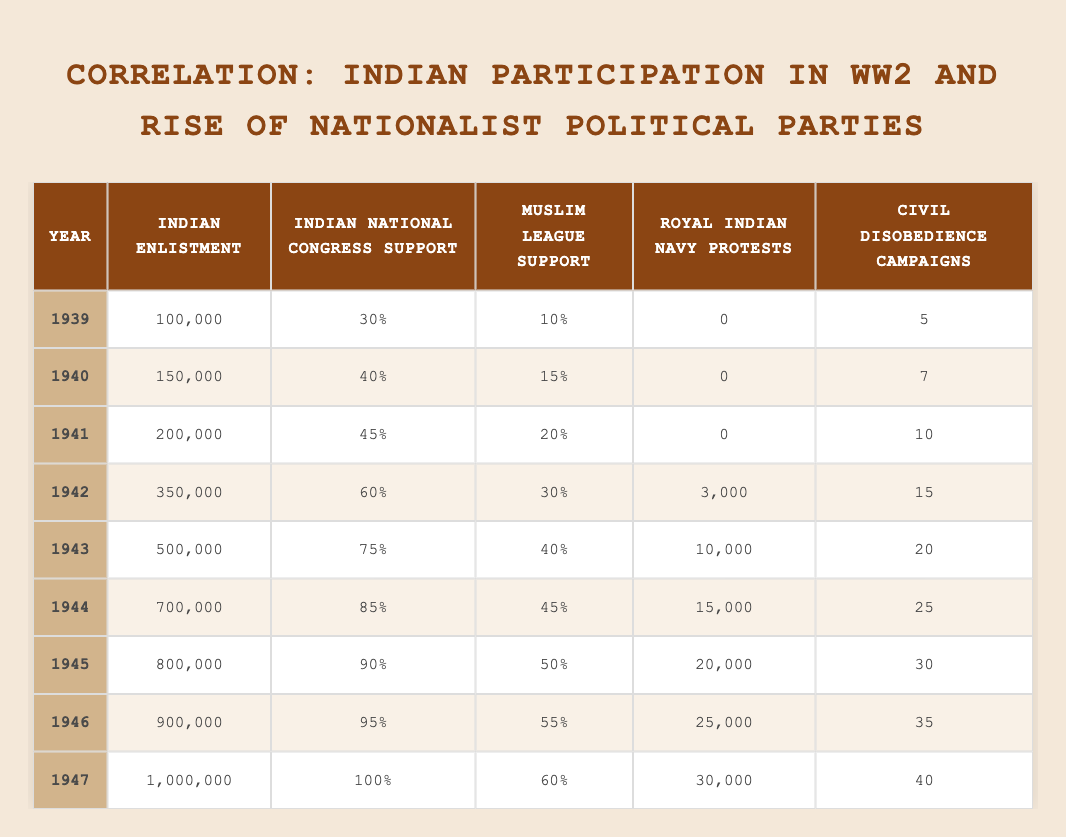What was the Indian enlistment in 1944? In the table, under the Year 1944, the Indian Enlistment value is listed as 700,000.
Answer: 700,000 What was the percentage of Indian National Congress support in 1942? The table shows the Indian National Congress support for the year 1942 as 60%.
Answer: 60% Was there any Royal Indian Navy Protests in 1940? Looking at the table for the year 1940, the value for Royal Indian Navy Protests is 0, which indicates that there were no protests that year.
Answer: No What is the total Indian enlistment from 1940 to 1946? To find this, sum the Indian enlistment values from 1940 to 1946: 150,000 + 200,000 + 350,000 + 500,000 + 700,000 + 800,000 + 900,000 = 2,600,000.
Answer: 2,600,000 What is the difference in percentage support for the Indian National Congress between 1945 and 1941? The Indian National Congress support in 1945 is 90% and in 1941 is 45%. The difference is 90% - 45% = 45%.
Answer: 45% How many Civil Disobedience Campaigns were reported in 1943? The table indicates that there were 20 Civil Disobedience Campaigns in 1943.
Answer: 20 In which year did the Royal Indian Navy Protests first appear? The first appearance of Royal Indian Navy Protests is in the year 1942, where the value is recorded as 3,000.
Answer: 1942 What was the average support percentage of the Muslim League from 1942 to 1947? To calculate the average, first find the total support for the Muslim League from 1942 to 1947: 30 + 40 + 45 + 50 + 55 + 60 = 280. Since there are 6 years (1942 to 1947), the average is 280 / 6 = 46.67%.
Answer: 46.67% How much did Indian enlistment increase from 1939 to 1947? The Indian enlistment in 1939 was 100,000, and in 1947 it was 1,000,000. The increase is 1,000,000 - 100,000 = 900,000.
Answer: 900,000 